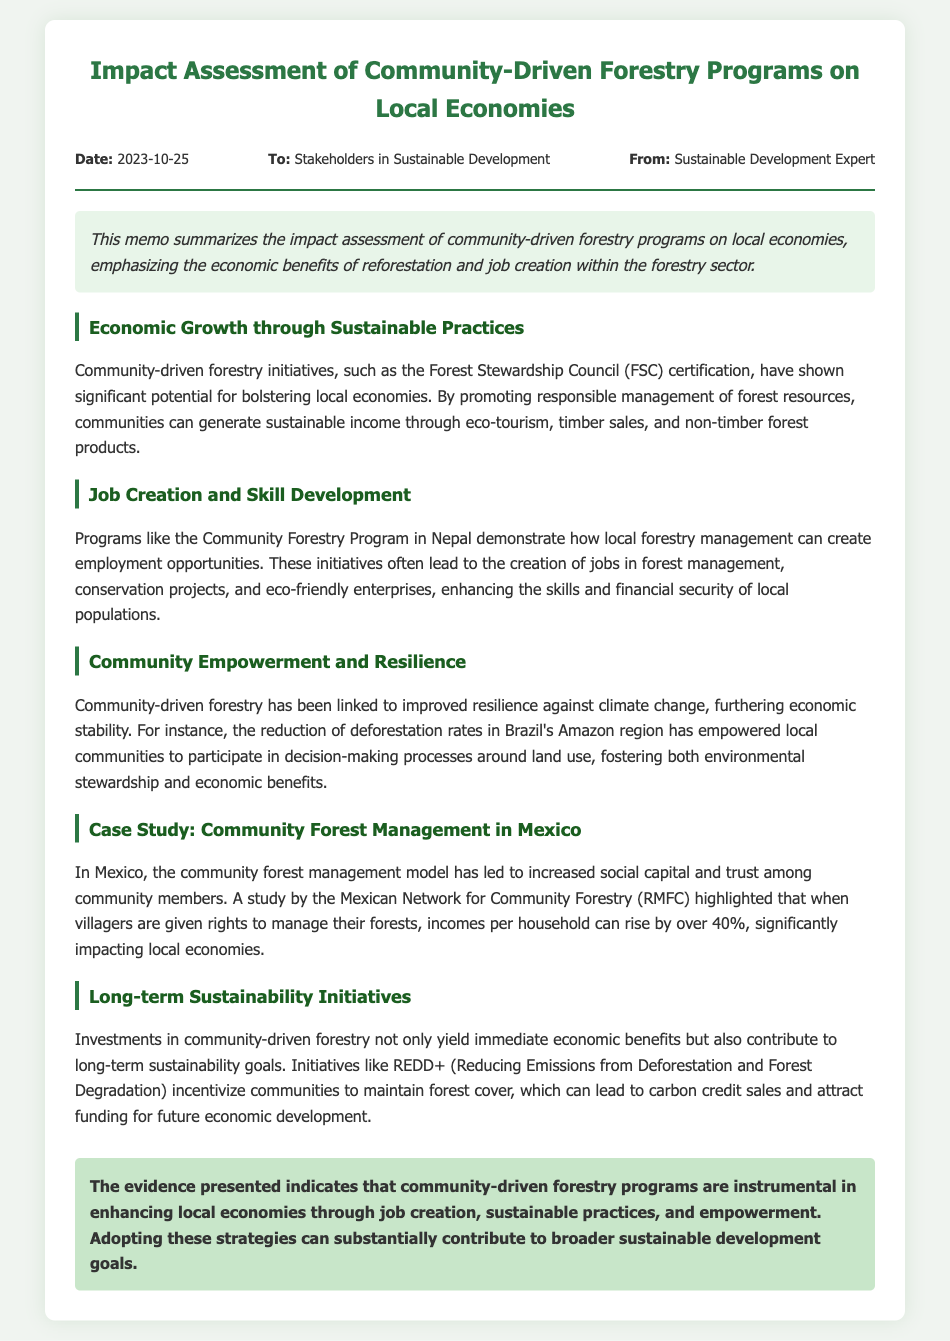what is the date of the memo? The date of the memo is located in the header section of the document.
Answer: 2023-10-25 who is the memo addressed to? The memo specifies the audience in the header section.
Answer: Stakeholders in Sustainable Development what program in Nepal is mentioned for job creation? The memo references a specific program in the section about job creation.
Answer: Community Forestry Program what economic benefit does eco-tourism provide? This benefit is outlined in the section about economic growth through sustainable practices.
Answer: Sustainable income which model leads to increased social capital in Mexico? The case study in the memo talks about a model that enhances community relationships.
Answer: Community forest management model how much can household incomes rise by in the Mexican case study? The memo provides a specific statistic related to income changes in the case study.
Answer: Over 40% what longer-term initiative is mentioned for sustainability? The document refers to a specific initiative aimed at long-term sustainability.
Answer: REDD+ what is the conclusion about community-driven forestry programs? The conclusion gives a summarization of the impact of these programs on local economies.
Answer: Instrumental in enhancing local economies 